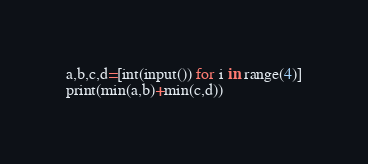Convert code to text. <code><loc_0><loc_0><loc_500><loc_500><_Python_>a,b,c,d=[int(input()) for i in range(4)]
print(min(a,b)+min(c,d))</code> 